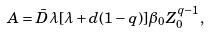Convert formula to latex. <formula><loc_0><loc_0><loc_500><loc_500>A = \bar { D } \lambda [ \lambda + d ( 1 - q ) ] \beta _ { 0 } Z _ { 0 } ^ { q - 1 } ,</formula> 